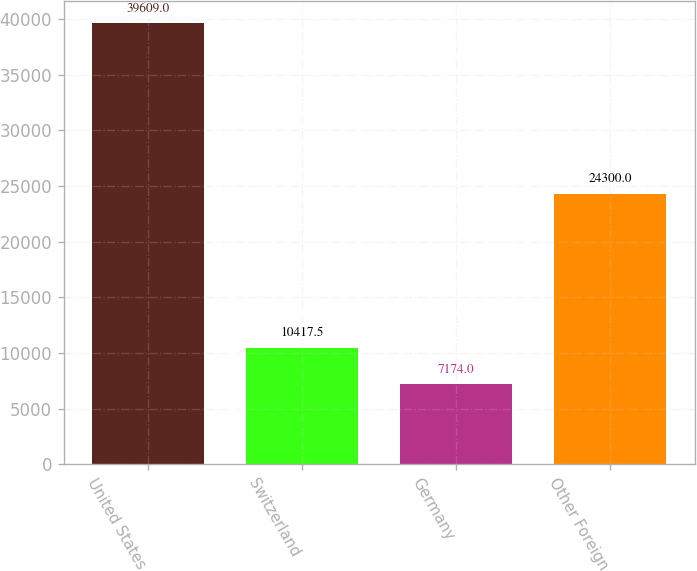Convert chart to OTSL. <chart><loc_0><loc_0><loc_500><loc_500><bar_chart><fcel>United States<fcel>Switzerland<fcel>Germany<fcel>Other Foreign<nl><fcel>39609<fcel>10417.5<fcel>7174<fcel>24300<nl></chart> 